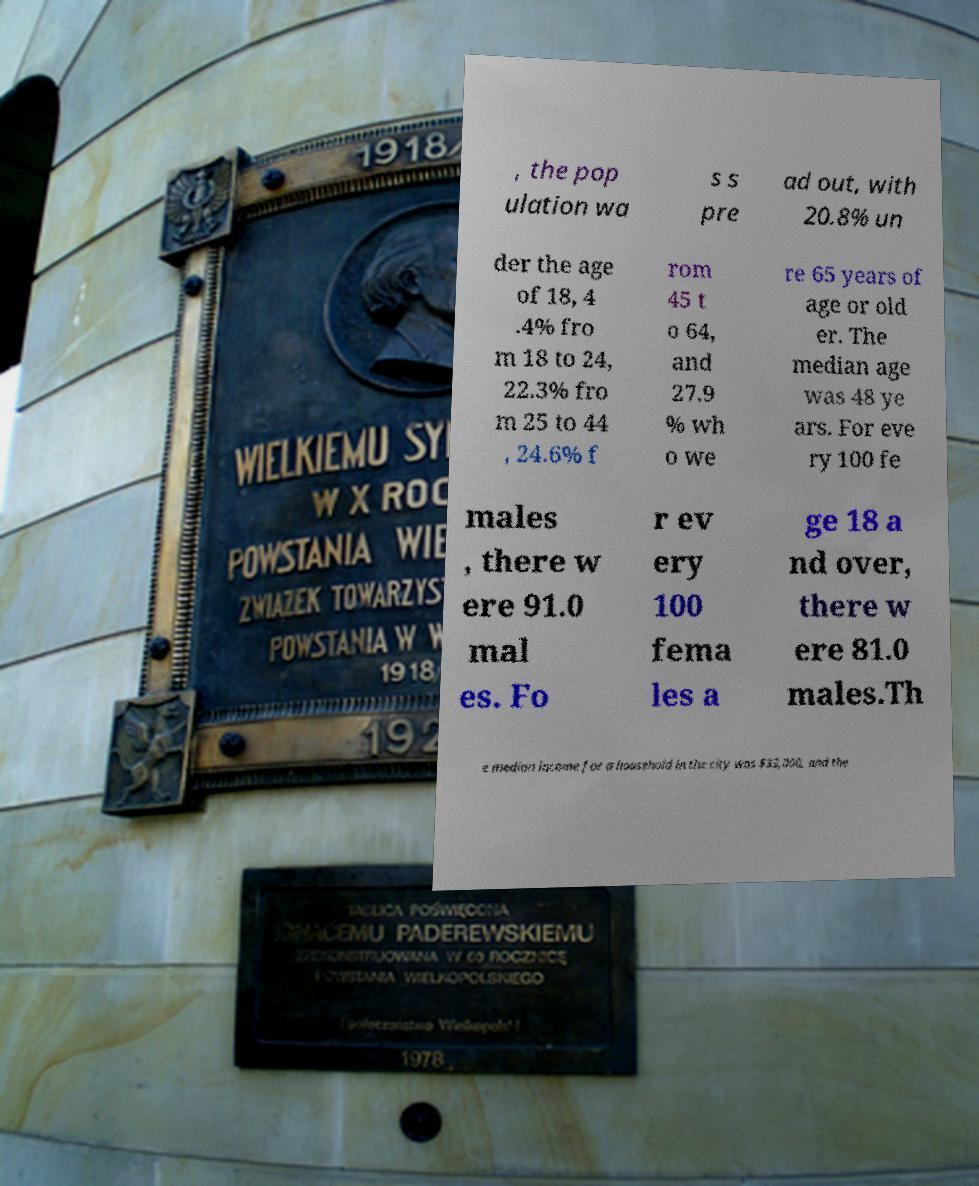Please read and relay the text visible in this image. What does it say? , the pop ulation wa s s pre ad out, with 20.8% un der the age of 18, 4 .4% fro m 18 to 24, 22.3% fro m 25 to 44 , 24.6% f rom 45 t o 64, and 27.9 % wh o we re 65 years of age or old er. The median age was 48 ye ars. For eve ry 100 fe males , there w ere 91.0 mal es. Fo r ev ery 100 fema les a ge 18 a nd over, there w ere 81.0 males.Th e median income for a household in the city was $33,000, and the 